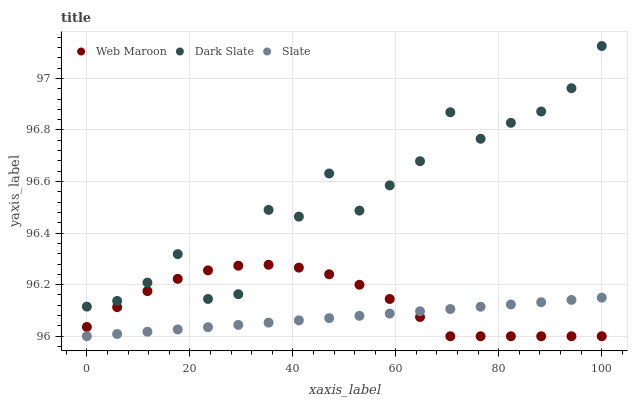Does Slate have the minimum area under the curve?
Answer yes or no. Yes. Does Dark Slate have the maximum area under the curve?
Answer yes or no. Yes. Does Web Maroon have the minimum area under the curve?
Answer yes or no. No. Does Web Maroon have the maximum area under the curve?
Answer yes or no. No. Is Slate the smoothest?
Answer yes or no. Yes. Is Dark Slate the roughest?
Answer yes or no. Yes. Is Web Maroon the smoothest?
Answer yes or no. No. Is Web Maroon the roughest?
Answer yes or no. No. Does Slate have the lowest value?
Answer yes or no. Yes. Does Dark Slate have the highest value?
Answer yes or no. Yes. Does Web Maroon have the highest value?
Answer yes or no. No. Is Slate less than Dark Slate?
Answer yes or no. Yes. Is Dark Slate greater than Slate?
Answer yes or no. Yes. Does Dark Slate intersect Web Maroon?
Answer yes or no. Yes. Is Dark Slate less than Web Maroon?
Answer yes or no. No. Is Dark Slate greater than Web Maroon?
Answer yes or no. No. Does Slate intersect Dark Slate?
Answer yes or no. No. 